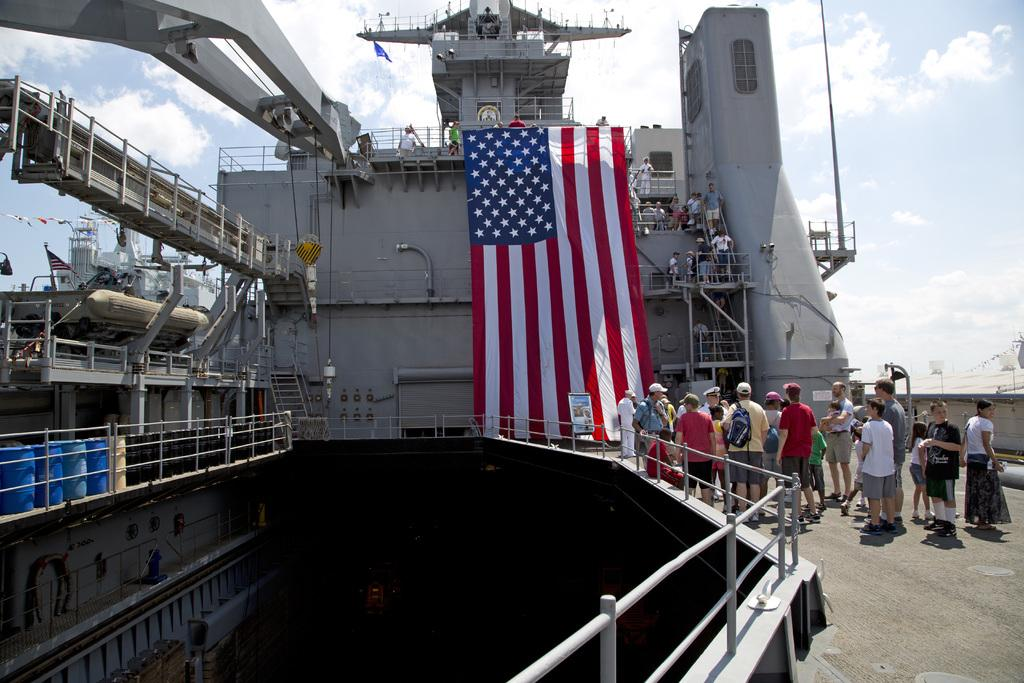What is the main subject in the middle of the image? There is a flag in the middle of the image. What else can be seen on the right side of the image? There are people standing on the right side of the image. What is visible at the top of the image? The sky is visible at the top of the image. What song is being sung by the people in the image? There is no indication in the image that the people are singing a song, so it cannot be determined from the picture. 